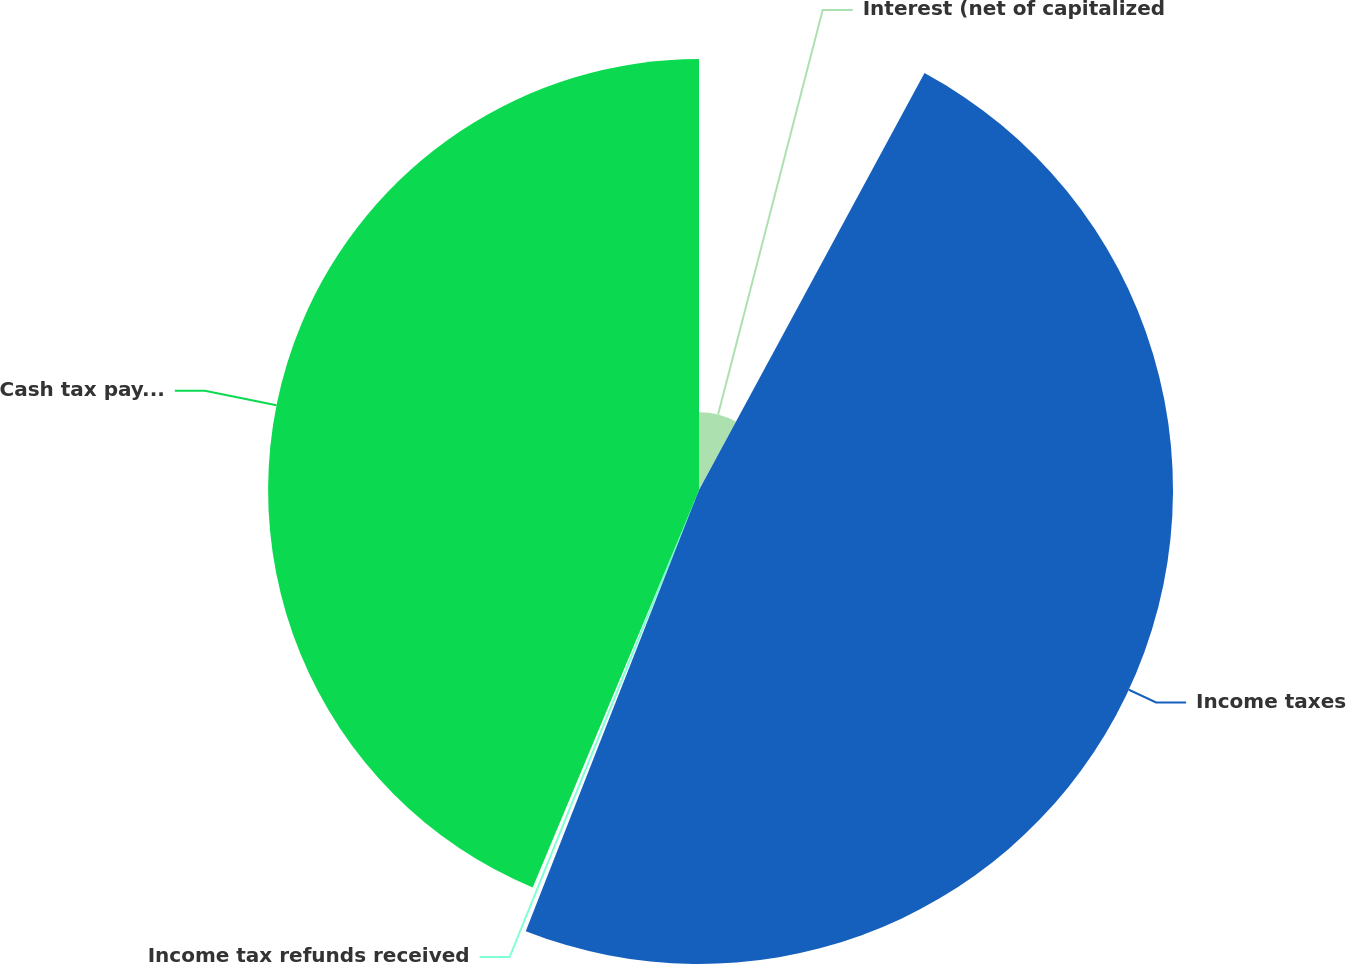Convert chart. <chart><loc_0><loc_0><loc_500><loc_500><pie_chart><fcel>Interest (net of capitalized<fcel>Income taxes<fcel>Income tax refunds received<fcel>Cash tax payments net<nl><fcel>7.89%<fcel>48.06%<fcel>0.35%<fcel>43.69%<nl></chart> 